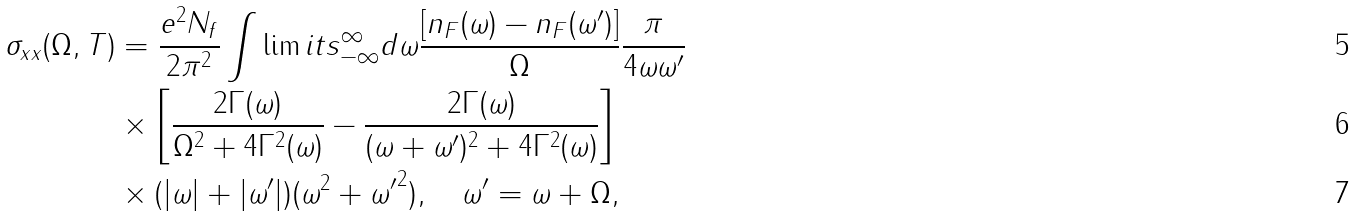Convert formula to latex. <formula><loc_0><loc_0><loc_500><loc_500>\sigma _ { x x } ( \Omega , T ) & = \frac { e ^ { 2 } N _ { f } } { 2 \pi ^ { 2 } } \int \lim i t s _ { - \infty } ^ { \infty } d \omega \frac { [ n _ { F } ( \omega ) - n _ { F } ( \omega ^ { \prime } ) ] } { \Omega } \frac { \pi } { 4 \omega \omega ^ { \prime } } \\ & \times \left [ \frac { 2 \Gamma ( \omega ) } { \Omega ^ { 2 } + 4 \Gamma ^ { 2 } ( \omega ) } - \frac { 2 \Gamma ( \omega ) } { ( \omega + \omega ^ { \prime } ) ^ { 2 } + 4 \Gamma ^ { 2 } ( \omega ) } \right ] \\ & \times ( | \omega | + | \omega ^ { \prime } | ) ( \omega ^ { 2 } + { \omega ^ { \prime } } ^ { 2 } ) , \quad \omega ^ { \prime } = \omega + \Omega ,</formula> 